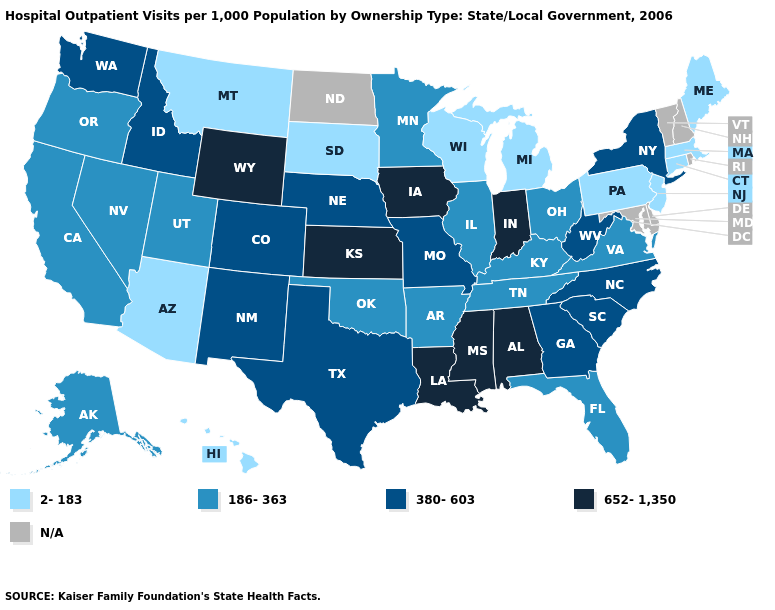What is the lowest value in states that border Massachusetts?
Be succinct. 2-183. What is the highest value in states that border Minnesota?
Be succinct. 652-1,350. Which states have the lowest value in the USA?
Be succinct. Arizona, Connecticut, Hawaii, Maine, Massachusetts, Michigan, Montana, New Jersey, Pennsylvania, South Dakota, Wisconsin. Which states hav the highest value in the MidWest?
Answer briefly. Indiana, Iowa, Kansas. Name the states that have a value in the range N/A?
Keep it brief. Delaware, Maryland, New Hampshire, North Dakota, Rhode Island, Vermont. What is the highest value in the West ?
Give a very brief answer. 652-1,350. What is the value of Idaho?
Give a very brief answer. 380-603. Name the states that have a value in the range 380-603?
Answer briefly. Colorado, Georgia, Idaho, Missouri, Nebraska, New Mexico, New York, North Carolina, South Carolina, Texas, Washington, West Virginia. Which states have the lowest value in the West?
Be succinct. Arizona, Hawaii, Montana. Name the states that have a value in the range N/A?
Answer briefly. Delaware, Maryland, New Hampshire, North Dakota, Rhode Island, Vermont. Does Kansas have the highest value in the MidWest?
Write a very short answer. Yes. Which states have the lowest value in the Northeast?
Write a very short answer. Connecticut, Maine, Massachusetts, New Jersey, Pennsylvania. What is the value of Florida?
Short answer required. 186-363. 